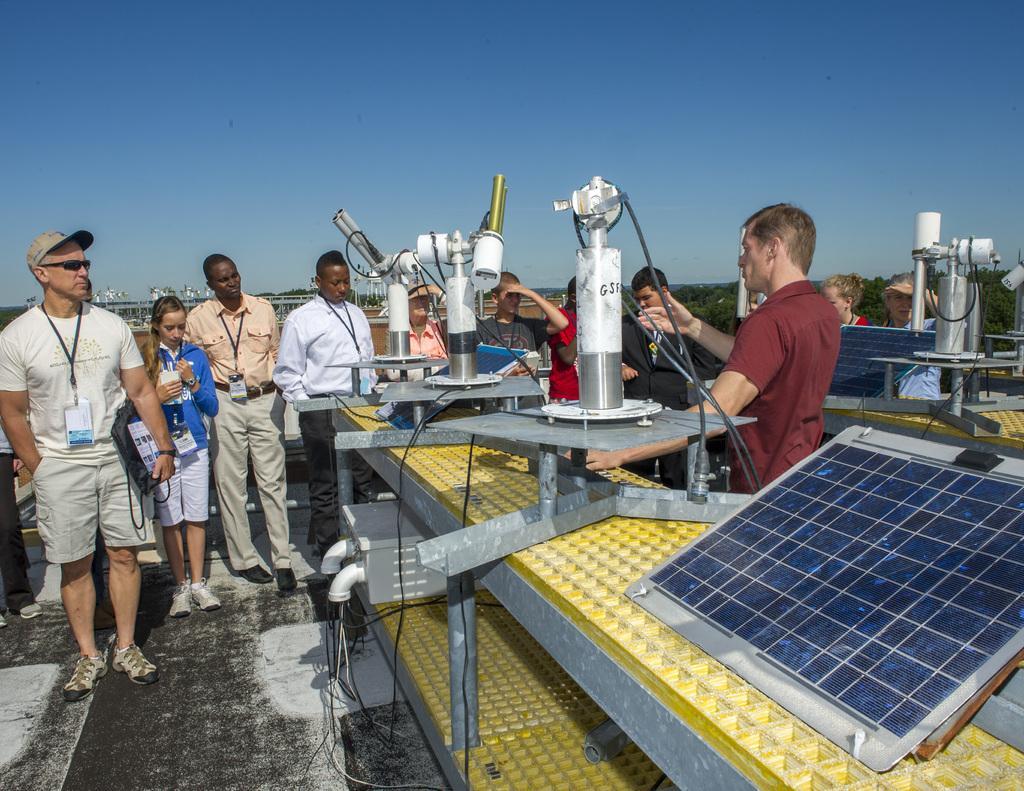Can you describe this image briefly? In this image many people are standing. Here there are machines. This is a solar panel. In the background there are trees. The sky is clear. 